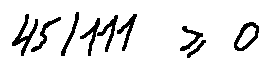Convert formula to latex. <formula><loc_0><loc_0><loc_500><loc_500>4 5 / 1 1 1 \geq 0</formula> 